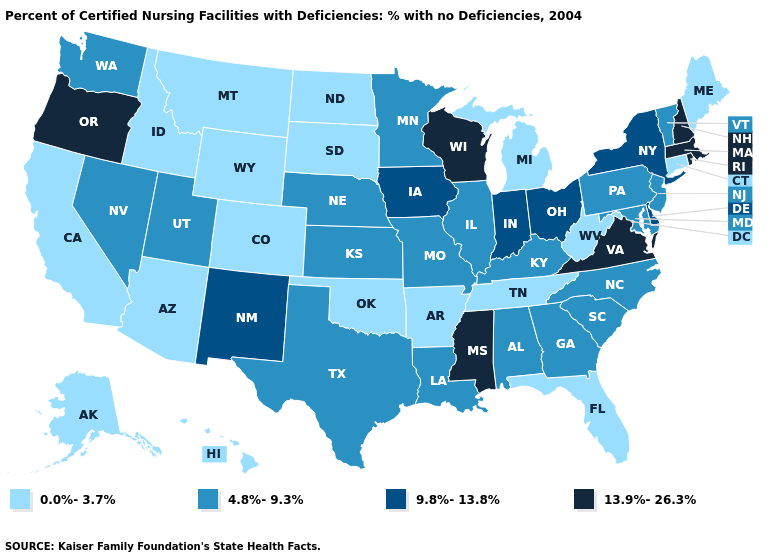Name the states that have a value in the range 9.8%-13.8%?
Be succinct. Delaware, Indiana, Iowa, New Mexico, New York, Ohio. What is the lowest value in states that border North Dakota?
Answer briefly. 0.0%-3.7%. Does New Mexico have a lower value than New Hampshire?
Give a very brief answer. Yes. Does Oregon have the highest value in the USA?
Quick response, please. Yes. What is the highest value in the Northeast ?
Give a very brief answer. 13.9%-26.3%. Does New Mexico have the same value as Indiana?
Give a very brief answer. Yes. What is the lowest value in states that border North Carolina?
Be succinct. 0.0%-3.7%. Name the states that have a value in the range 0.0%-3.7%?
Be succinct. Alaska, Arizona, Arkansas, California, Colorado, Connecticut, Florida, Hawaii, Idaho, Maine, Michigan, Montana, North Dakota, Oklahoma, South Dakota, Tennessee, West Virginia, Wyoming. Does Delaware have the highest value in the USA?
Be succinct. No. Does Illinois have a higher value than Oklahoma?
Give a very brief answer. Yes. What is the highest value in the USA?
Answer briefly. 13.9%-26.3%. Does Minnesota have the highest value in the USA?
Quick response, please. No. Name the states that have a value in the range 0.0%-3.7%?
Be succinct. Alaska, Arizona, Arkansas, California, Colorado, Connecticut, Florida, Hawaii, Idaho, Maine, Michigan, Montana, North Dakota, Oklahoma, South Dakota, Tennessee, West Virginia, Wyoming. What is the lowest value in states that border Pennsylvania?
Be succinct. 0.0%-3.7%. Name the states that have a value in the range 9.8%-13.8%?
Concise answer only. Delaware, Indiana, Iowa, New Mexico, New York, Ohio. 